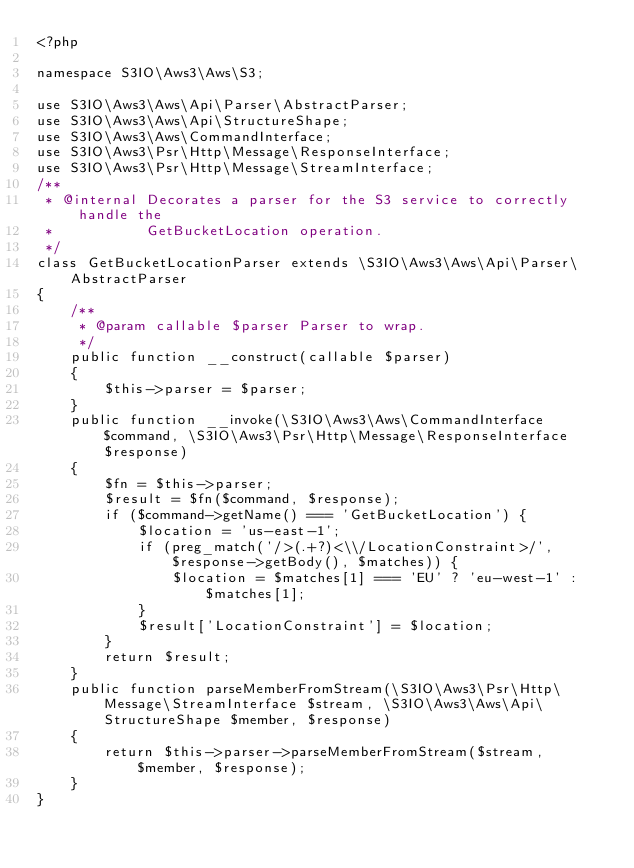<code> <loc_0><loc_0><loc_500><loc_500><_PHP_><?php

namespace S3IO\Aws3\Aws\S3;

use S3IO\Aws3\Aws\Api\Parser\AbstractParser;
use S3IO\Aws3\Aws\Api\StructureShape;
use S3IO\Aws3\Aws\CommandInterface;
use S3IO\Aws3\Psr\Http\Message\ResponseInterface;
use S3IO\Aws3\Psr\Http\Message\StreamInterface;
/**
 * @internal Decorates a parser for the S3 service to correctly handle the
 *           GetBucketLocation operation.
 */
class GetBucketLocationParser extends \S3IO\Aws3\Aws\Api\Parser\AbstractParser
{
    /**
     * @param callable $parser Parser to wrap.
     */
    public function __construct(callable $parser)
    {
        $this->parser = $parser;
    }
    public function __invoke(\S3IO\Aws3\Aws\CommandInterface $command, \S3IO\Aws3\Psr\Http\Message\ResponseInterface $response)
    {
        $fn = $this->parser;
        $result = $fn($command, $response);
        if ($command->getName() === 'GetBucketLocation') {
            $location = 'us-east-1';
            if (preg_match('/>(.+?)<\\/LocationConstraint>/', $response->getBody(), $matches)) {
                $location = $matches[1] === 'EU' ? 'eu-west-1' : $matches[1];
            }
            $result['LocationConstraint'] = $location;
        }
        return $result;
    }
    public function parseMemberFromStream(\S3IO\Aws3\Psr\Http\Message\StreamInterface $stream, \S3IO\Aws3\Aws\Api\StructureShape $member, $response)
    {
        return $this->parser->parseMemberFromStream($stream, $member, $response);
    }
}
</code> 